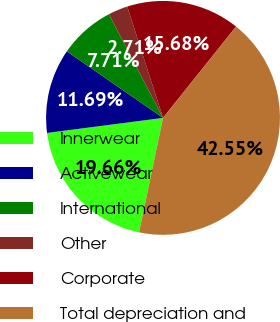Convert chart to OTSL. <chart><loc_0><loc_0><loc_500><loc_500><pie_chart><fcel>Innerwear<fcel>Activewear<fcel>International<fcel>Other<fcel>Corporate<fcel>Total depreciation and<nl><fcel>19.66%<fcel>11.69%<fcel>7.71%<fcel>2.71%<fcel>15.68%<fcel>42.55%<nl></chart> 